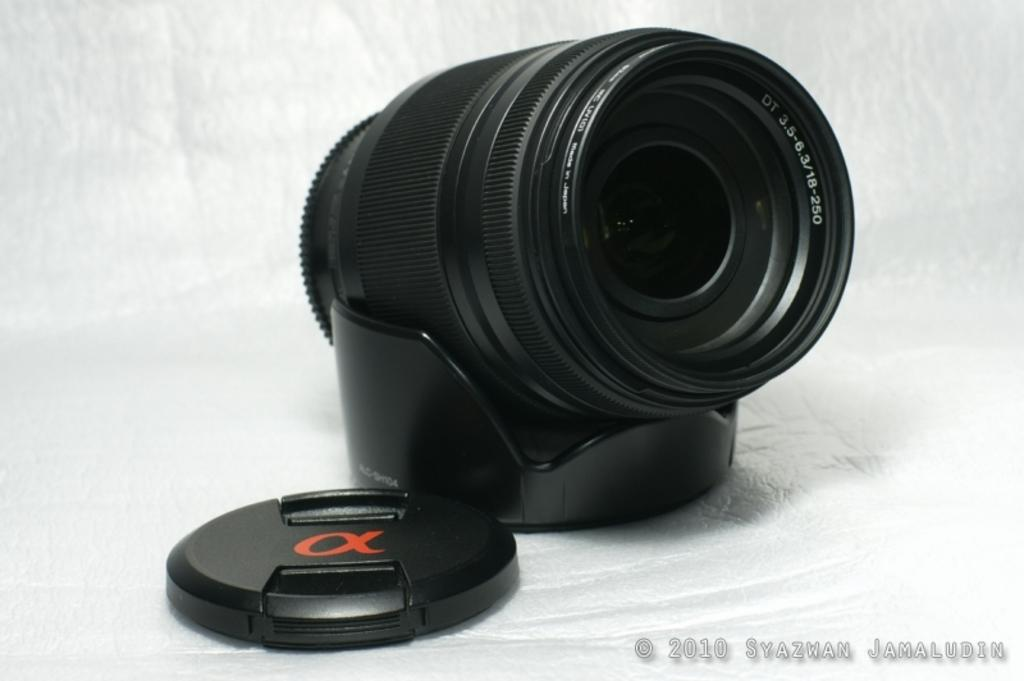<image>
Present a compact description of the photo's key features. A scope that has DT 3.5-6.3/18-250 on the inside of it 